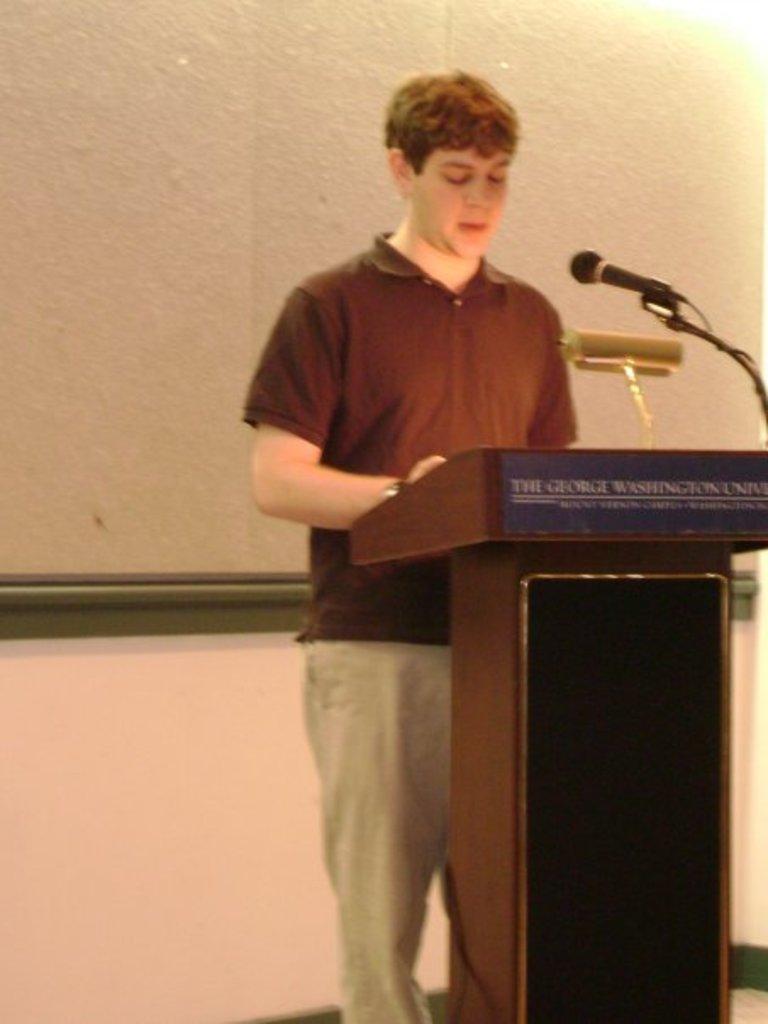How would you summarize this image in a sentence or two? In this picture we can see a man is standing behind the podium and on the podium there is an object and a microphone with stand and a cable. Behind the man it looks like a projector screen on the wall. 